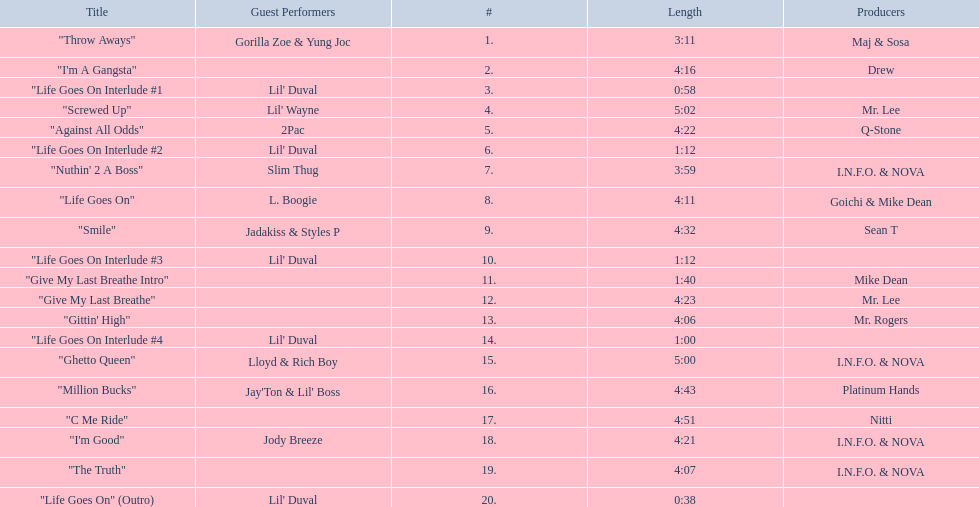How many tracks on trae's album "life goes on"? 20. 